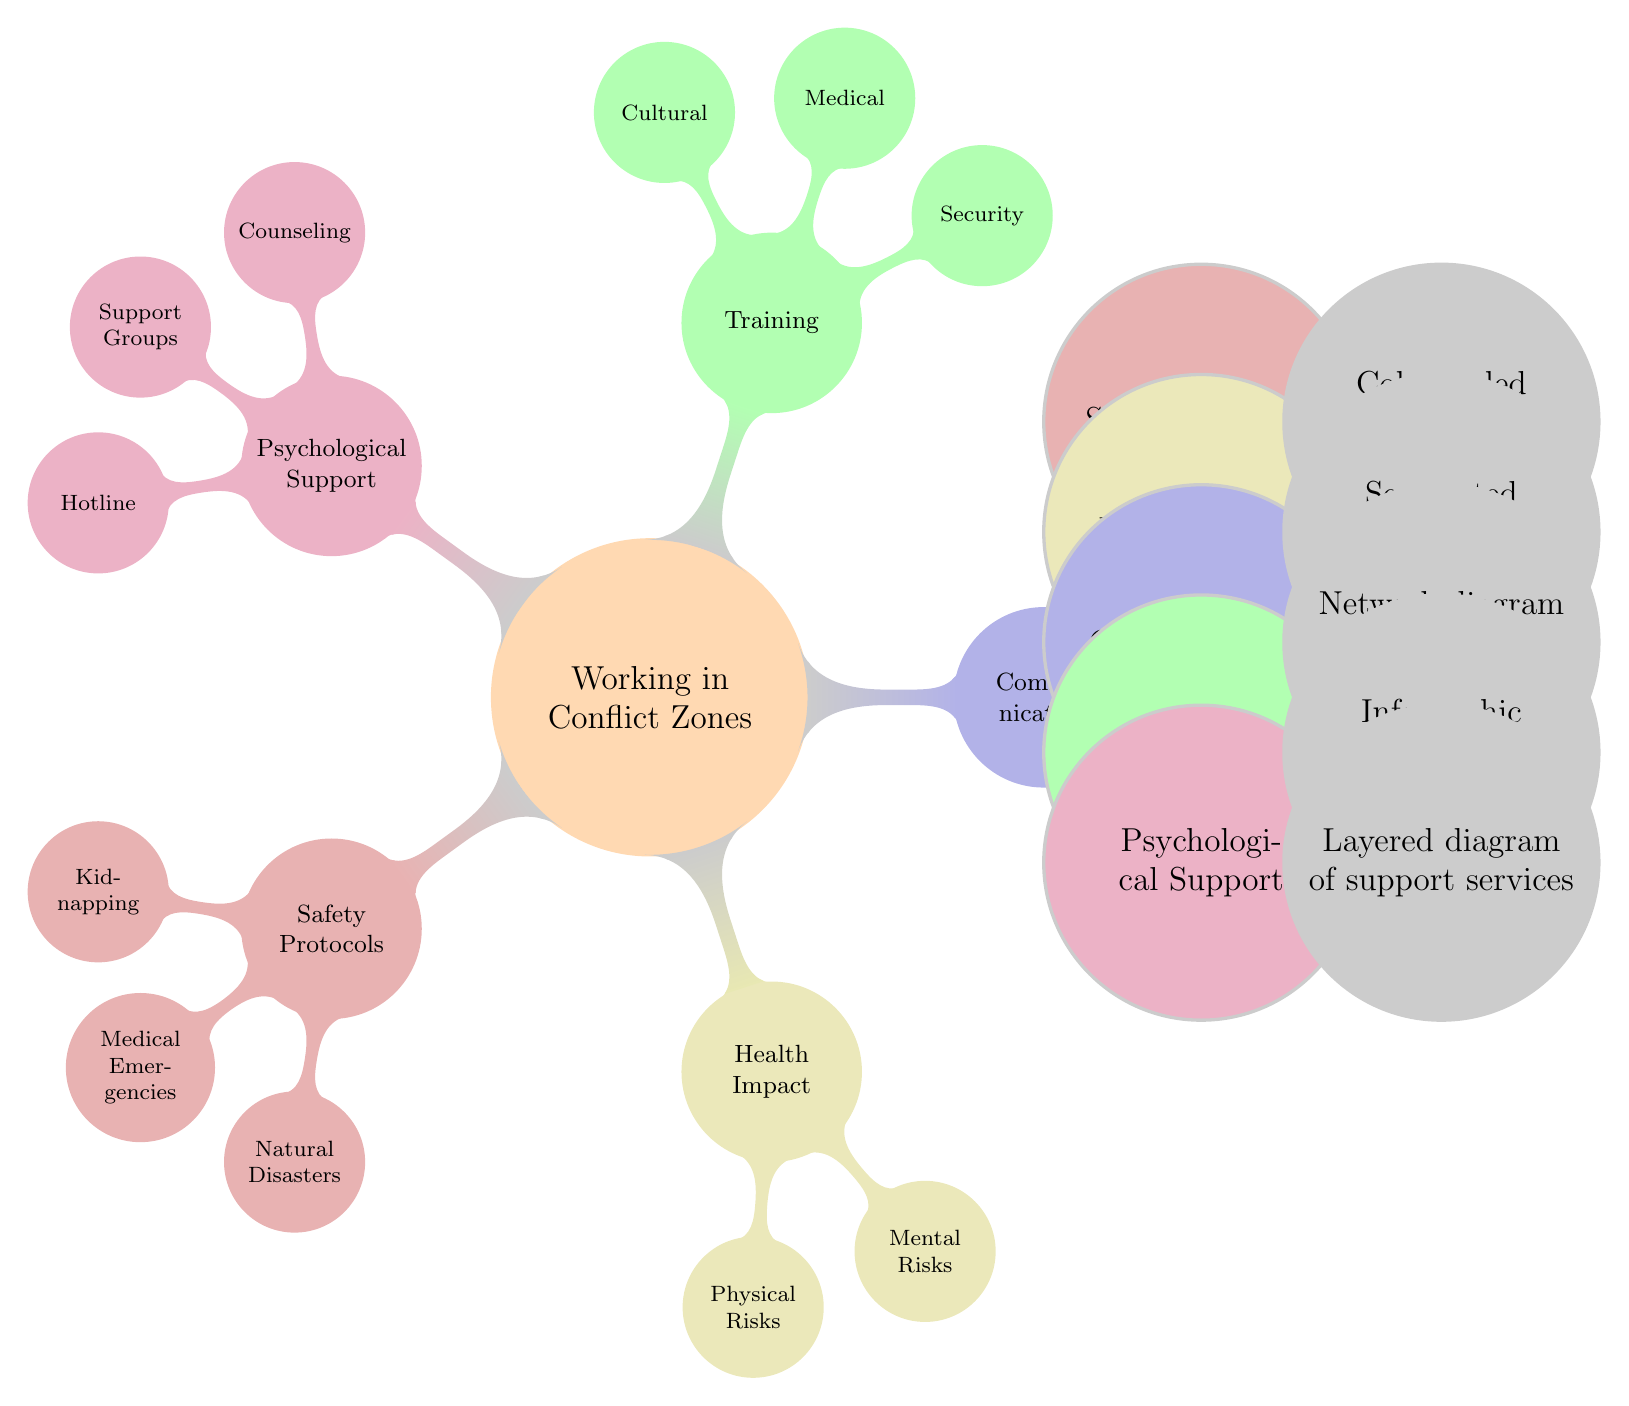What are the two categories listed under Health Impact? The diagram shows that Health Impact is divided into two subcategories: Physical Risks and Mental Risks. Both of these categories can be seen clearly branching from the Health Impact main node.
Answer: Physical Risks, Mental Risks How many nodes are there in the Training section? In the diagram, the Training section includes three nodes: Security, Medical, and Cultural. Counting these gives a total of three nodes in Training.
Answer: 3 Which node relates to crisis management in the Safety Protocols? The specific node related to crisis management within Safety Protocols is Kidnapping, as it deals with specific safety measures during such a crisis scenario.
Answer: Kidnapping What type of diagram is used for depicting Communication channels? The diagram explicitly states that a Network diagram is used for representing the Communication section.
Answer: Network diagram What is the purpose of the Psychological Support category? The purpose of the Psychological Support category is represented by its three sub-nodes: Counseling, Support Groups, and Hotline, which collectively aim to provide mental health resources and support for workers' families.
Answer: Mental health resources Which section contains flowcharts and what do they depict? The Safety Protocols section contains flowcharts depicting different scenarios like Kidnapping, Medical Emergencies, and Natural Disasters for emergency responses.
Answer: Safety Protocols What are the three main training components indicated in the Training section? The main training components listed in the Training section are Security, Medical, and Cultural, indicating a comprehensive approach to preparation for conflict zone assignments.
Answer: Security, Medical, Cultural What illustrates potential health risks in the Health Impact section? In the Health Impact section, Segmented bar graphs are used to illustrate the potential physical and mental health risks associated with working in conflict zones.
Answer: Segmented bar graphs 